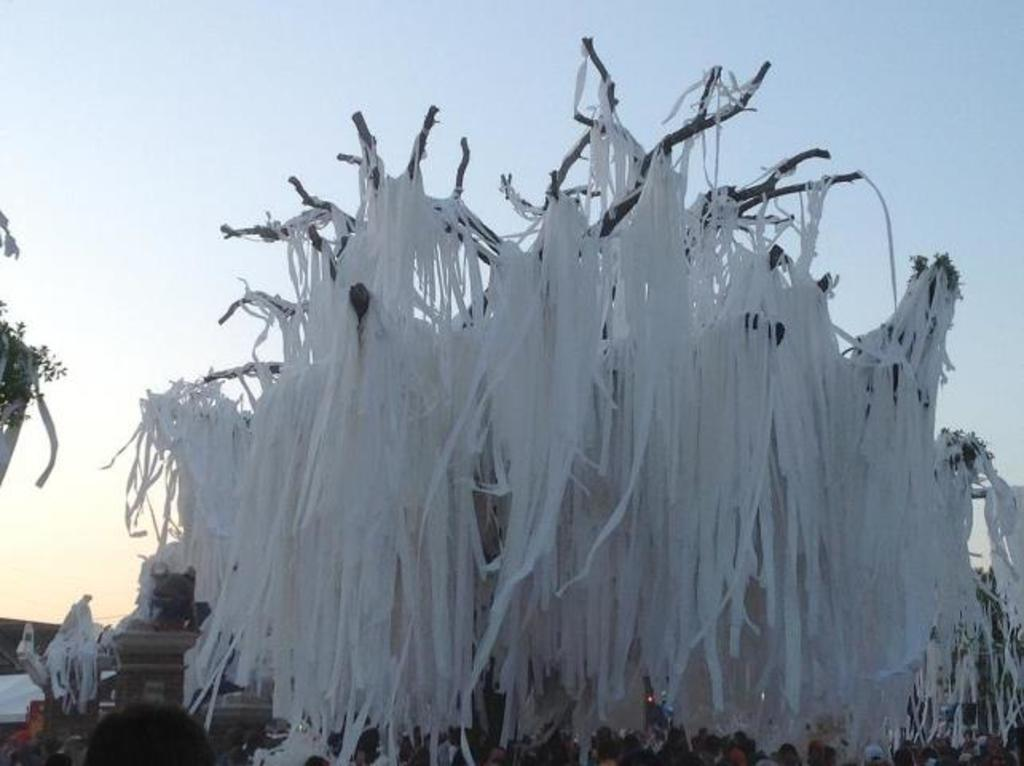What is the setting of the image? The image is an outside view. What can be seen attached to the tree in the image? There are white color ribbons attached to a tree. What is happening at the bottom of the image? There is a crowd of people at the bottom of the image. What is visible at the top of the image? The sky is visible at the top of the image. What type of holiday is being celebrated by the crowd in the image? There is no indication of a holiday being celebrated in the image; it simply shows a crowd of people and white color ribbons attached to a tree. Can you tell me how many lanes are present on the road in the image? There is no road present in the image; it is an outside view with a tree, ribbons, sky, and a crowd of people. 